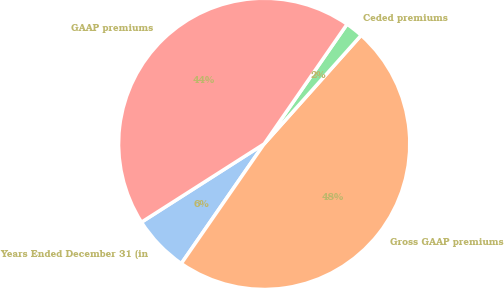<chart> <loc_0><loc_0><loc_500><loc_500><pie_chart><fcel>Years Ended December 31 (in<fcel>Gross GAAP premiums<fcel>Ceded premiums<fcel>GAAP premiums<nl><fcel>6.32%<fcel>48.04%<fcel>1.96%<fcel>43.68%<nl></chart> 